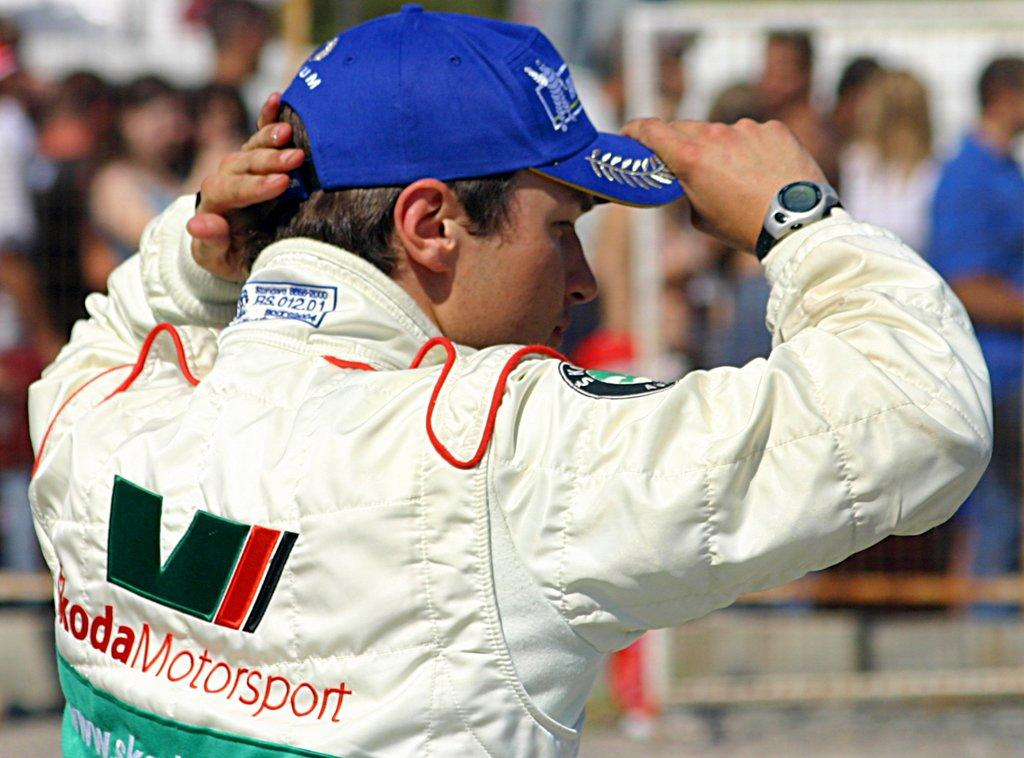<image>
Summarize the visual content of the image. A driver wearing a jacket that says Koda Motorsport on it. 